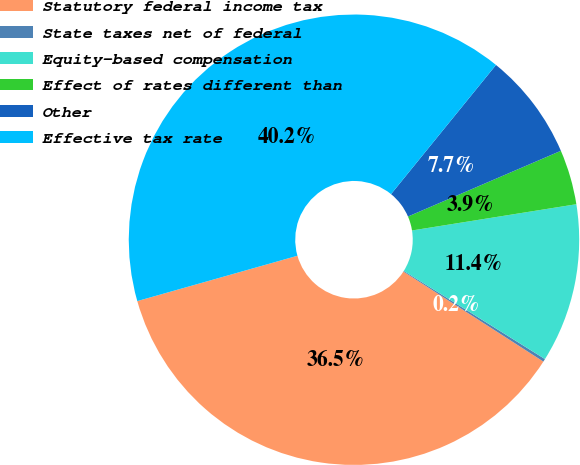Convert chart to OTSL. <chart><loc_0><loc_0><loc_500><loc_500><pie_chart><fcel>Statutory federal income tax<fcel>State taxes net of federal<fcel>Equity-based compensation<fcel>Effect of rates different than<fcel>Other<fcel>Effective tax rate<nl><fcel>36.51%<fcel>0.21%<fcel>11.41%<fcel>3.94%<fcel>7.68%<fcel>40.25%<nl></chart> 